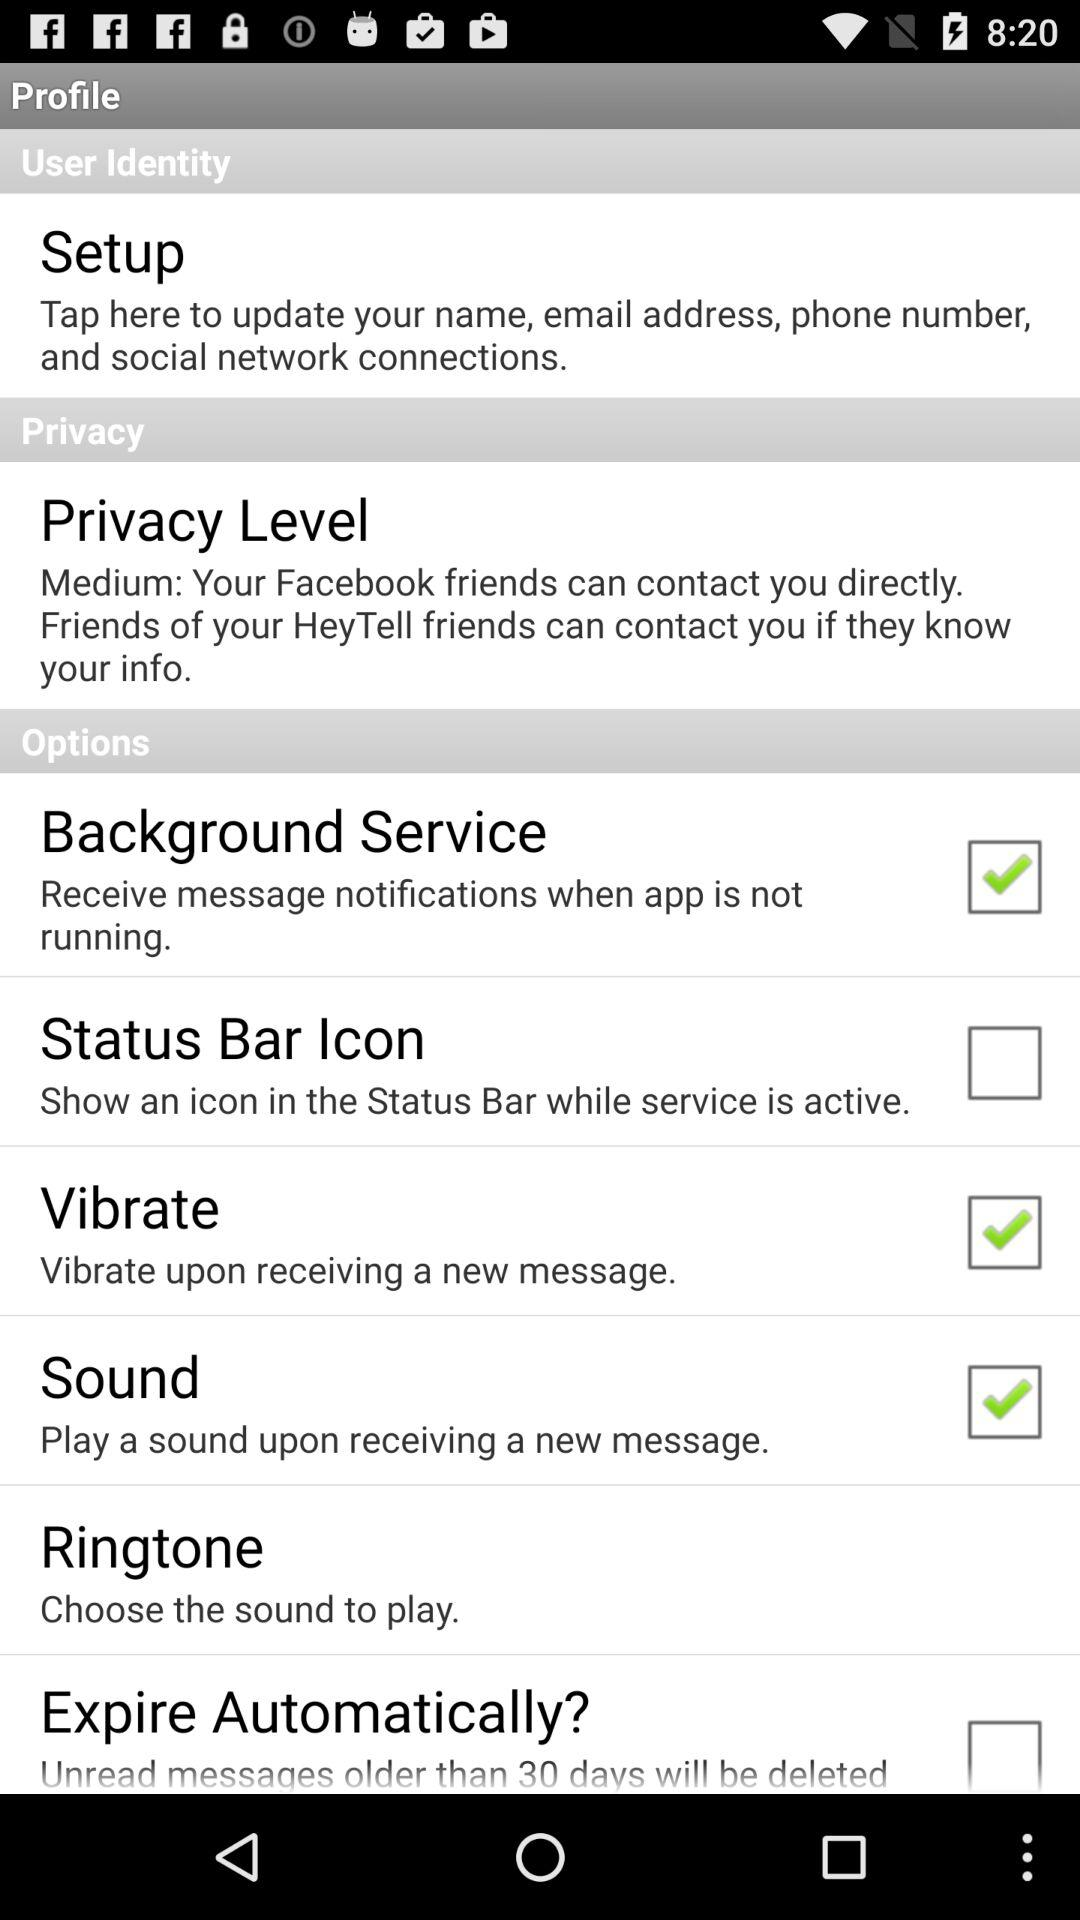Is the "Sound" option checked or unchecked? The "Sound" option is checked. 